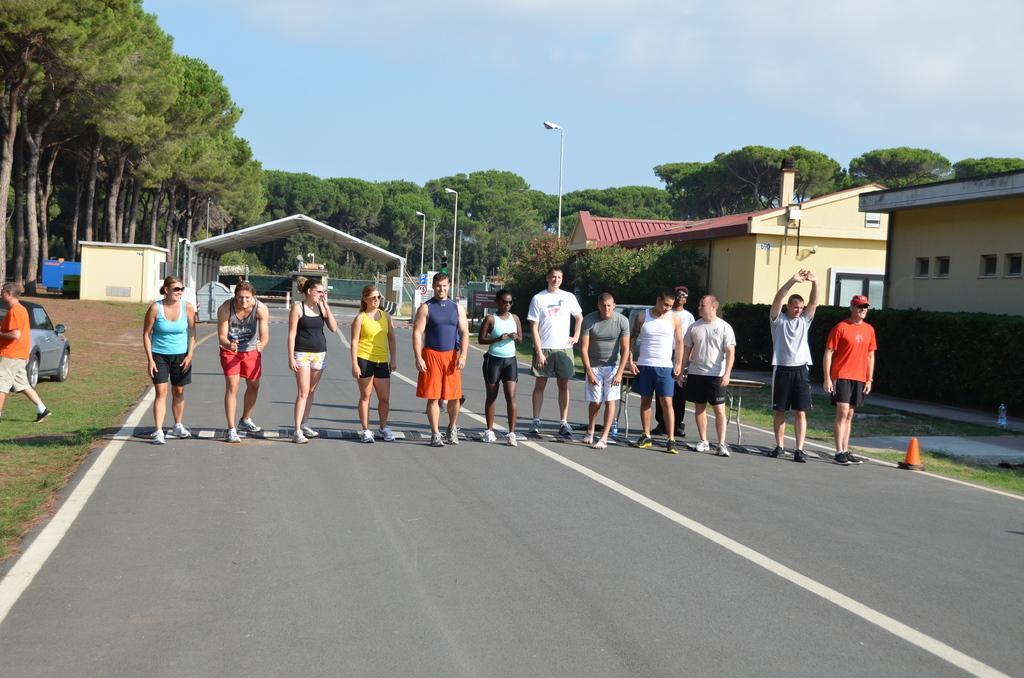Can you describe this image briefly? In this image there are people standing on the road. Left side there is a person walking on the land having some grass. There is a vehicle on the grassland. There are street lights. Right side there are plants. Background there are buildings and trees. Top of the image there is sky. 